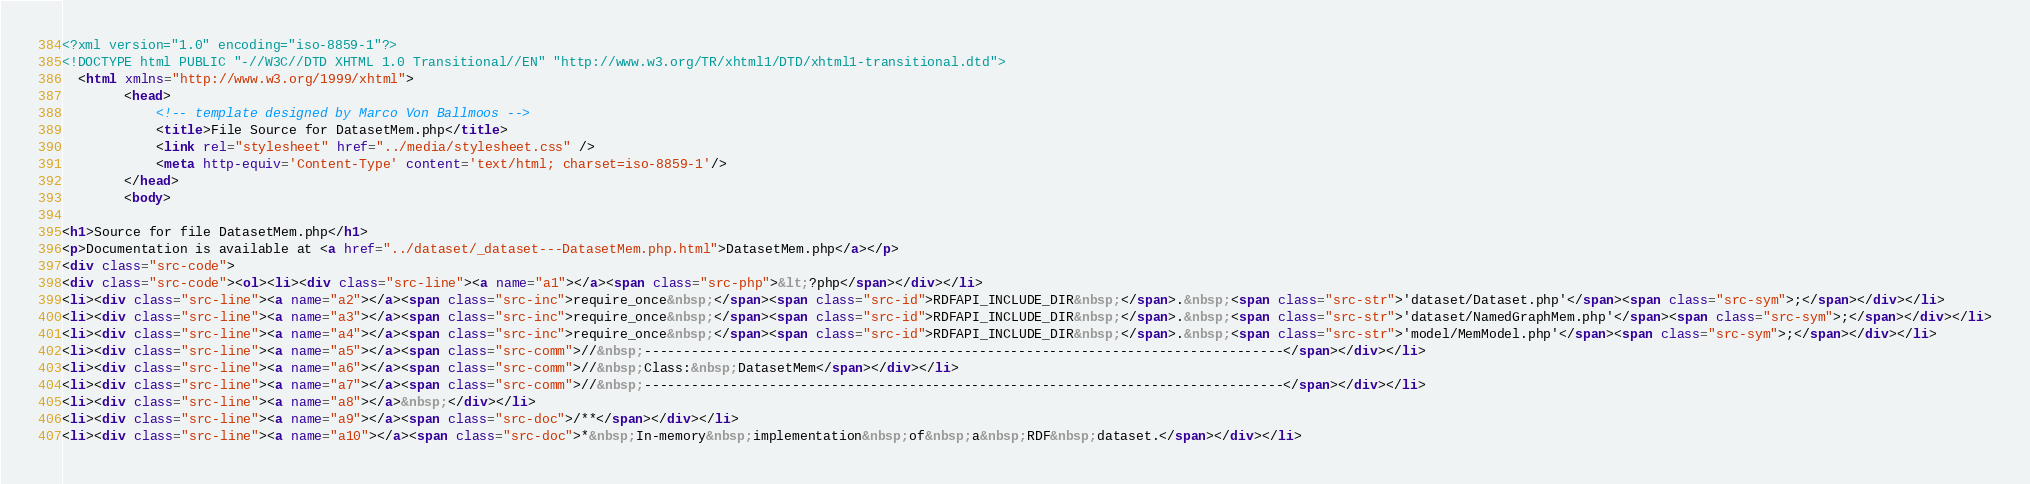Convert code to text. <code><loc_0><loc_0><loc_500><loc_500><_HTML_><?xml version="1.0" encoding="iso-8859-1"?>
<!DOCTYPE html PUBLIC "-//W3C//DTD XHTML 1.0 Transitional//EN" "http://www.w3.org/TR/xhtml1/DTD/xhtml1-transitional.dtd">
  <html xmlns="http://www.w3.org/1999/xhtml">
		<head>
			<!-- template designed by Marco Von Ballmoos -->
			<title>File Source for DatasetMem.php</title>
			<link rel="stylesheet" href="../media/stylesheet.css" />
			<meta http-equiv='Content-Type' content='text/html; charset=iso-8859-1'/>
		</head>
		<body>
						
<h1>Source for file DatasetMem.php</h1>
<p>Documentation is available at <a href="../dataset/_dataset---DatasetMem.php.html">DatasetMem.php</a></p>
<div class="src-code">
<div class="src-code"><ol><li><div class="src-line"><a name="a1"></a><span class="src-php">&lt;?php</span></div></li>
<li><div class="src-line"><a name="a2"></a><span class="src-inc">require_once&nbsp;</span><span class="src-id">RDFAPI_INCLUDE_DIR&nbsp;</span>.&nbsp;<span class="src-str">'dataset/Dataset.php'</span><span class="src-sym">;</span></div></li>
<li><div class="src-line"><a name="a3"></a><span class="src-inc">require_once&nbsp;</span><span class="src-id">RDFAPI_INCLUDE_DIR&nbsp;</span>.&nbsp;<span class="src-str">'dataset/NamedGraphMem.php'</span><span class="src-sym">;</span></div></li>
<li><div class="src-line"><a name="a4"></a><span class="src-inc">require_once&nbsp;</span><span class="src-id">RDFAPI_INCLUDE_DIR&nbsp;</span>.&nbsp;<span class="src-str">'model/MemModel.php'</span><span class="src-sym">;</span></div></li>
<li><div class="src-line"><a name="a5"></a><span class="src-comm">//&nbsp;----------------------------------------------------------------------------------</span></div></li>
<li><div class="src-line"><a name="a6"></a><span class="src-comm">//&nbsp;Class:&nbsp;DatasetMem</span></div></li>
<li><div class="src-line"><a name="a7"></a><span class="src-comm">//&nbsp;----------------------------------------------------------------------------------</span></div></li>
<li><div class="src-line"><a name="a8"></a>&nbsp;</div></li>
<li><div class="src-line"><a name="a9"></a><span class="src-doc">/**</span></div></li>
<li><div class="src-line"><a name="a10"></a><span class="src-doc">*&nbsp;In-memory&nbsp;implementation&nbsp;of&nbsp;a&nbsp;RDF&nbsp;dataset.</span></div></li></code> 